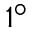<formula> <loc_0><loc_0><loc_500><loc_500>1 ^ { \circ }</formula> 